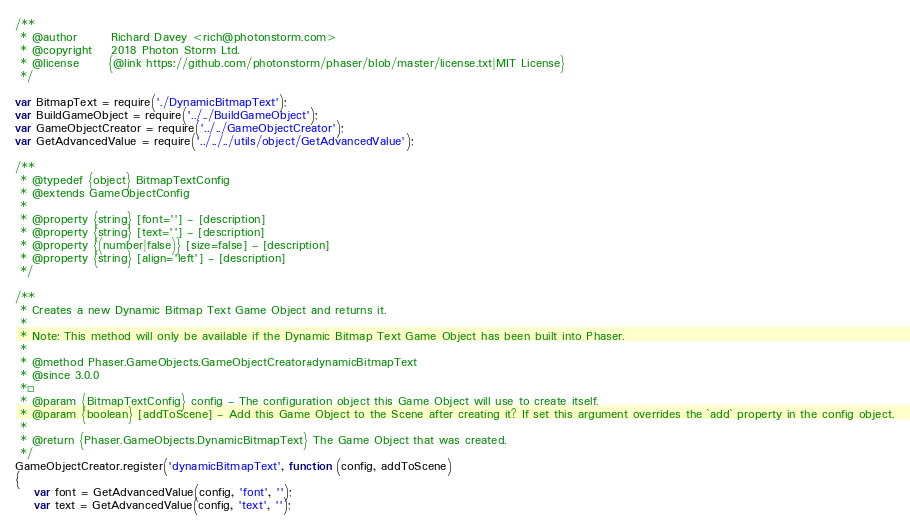<code> <loc_0><loc_0><loc_500><loc_500><_JavaScript_>/**
 * @author       Richard Davey <rich@photonstorm.com>
 * @copyright    2018 Photon Storm Ltd.
 * @license      {@link https://github.com/photonstorm/phaser/blob/master/license.txt|MIT License}
 */

var BitmapText = require('./DynamicBitmapText');
var BuildGameObject = require('../../BuildGameObject');
var GameObjectCreator = require('../../GameObjectCreator');
var GetAdvancedValue = require('../../../utils/object/GetAdvancedValue');

/**
 * @typedef {object} BitmapTextConfig
 * @extends GameObjectConfig
 *
 * @property {string} [font=''] - [description]
 * @property {string} [text=''] - [description]
 * @property {(number|false)} [size=false] - [description]
 * @property {string} [align='left'] - [description]
 */

/**
 * Creates a new Dynamic Bitmap Text Game Object and returns it.
 *
 * Note: This method will only be available if the Dynamic Bitmap Text Game Object has been built into Phaser.
 *
 * @method Phaser.GameObjects.GameObjectCreator#dynamicBitmapText
 * @since 3.0.0
 *²
 * @param {BitmapTextConfig} config - The configuration object this Game Object will use to create itself.
 * @param {boolean} [addToScene] - Add this Game Object to the Scene after creating it? If set this argument overrides the `add` property in the config object.
 *
 * @return {Phaser.GameObjects.DynamicBitmapText} The Game Object that was created.
 */
GameObjectCreator.register('dynamicBitmapText', function (config, addToScene)
{
    var font = GetAdvancedValue(config, 'font', '');
    var text = GetAdvancedValue(config, 'text', '');</code> 